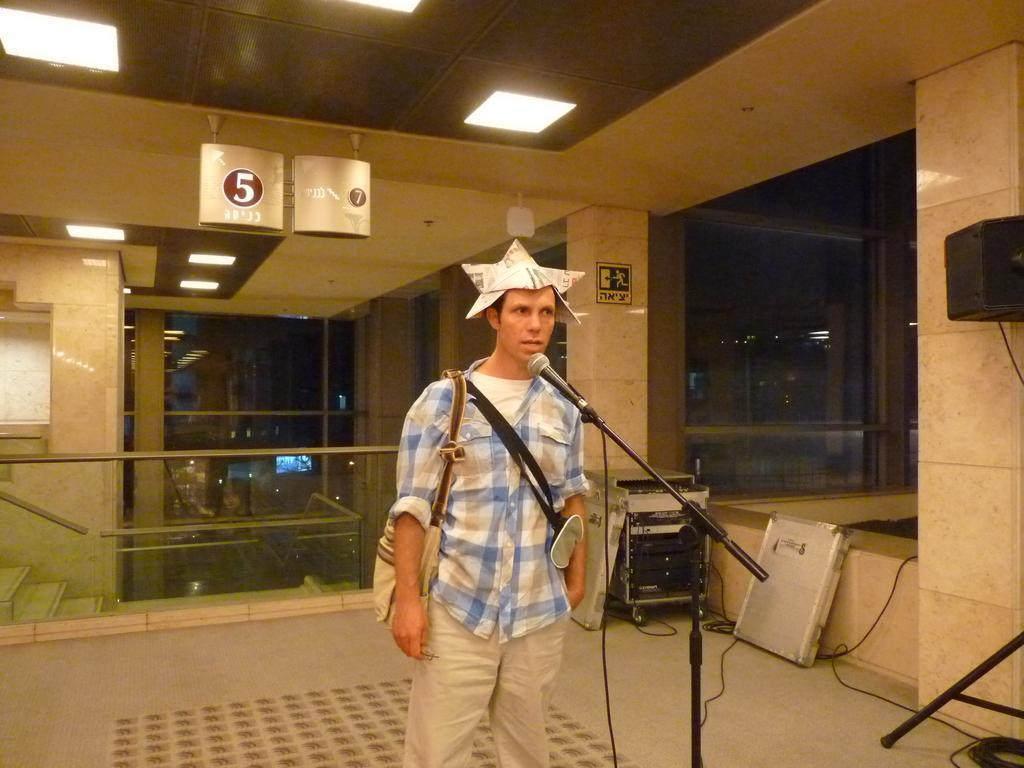Please provide a concise description of this image. In this picture there is a man in the center of the image and there is a mic in front of him and there is an electric box behind him, there is a speaker on the right side of the image and there are lamps on the floor at the top side of the image, there are glass windows in the image. 